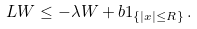<formula> <loc_0><loc_0><loc_500><loc_500>L W \leq - \lambda W + b 1 _ { \{ | x | \leq R \} } \, .</formula> 